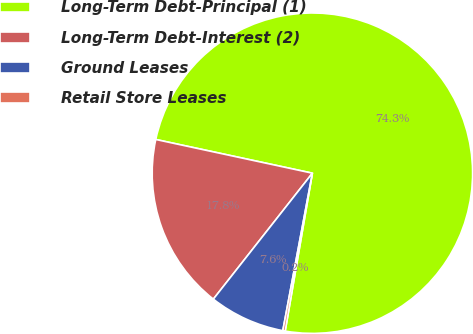Convert chart. <chart><loc_0><loc_0><loc_500><loc_500><pie_chart><fcel>Long-Term Debt-Principal (1)<fcel>Long-Term Debt-Interest (2)<fcel>Ground Leases<fcel>Retail Store Leases<nl><fcel>74.34%<fcel>17.77%<fcel>7.65%<fcel>0.24%<nl></chart> 